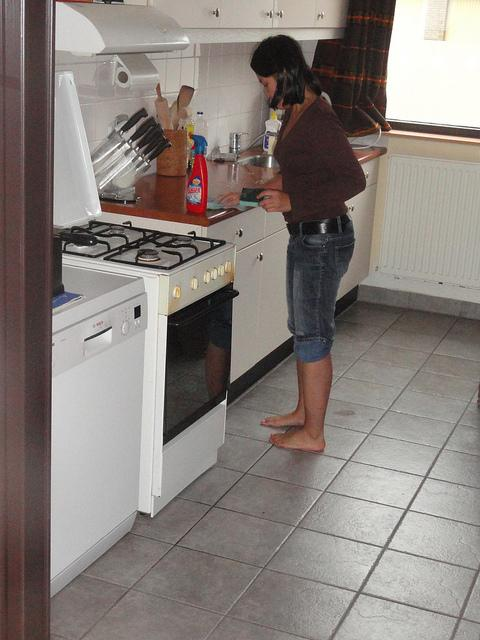How are dishes cleaned here? Please explain your reasoning. dishwashing machine. There is a dishwasher visible in the left corner. 